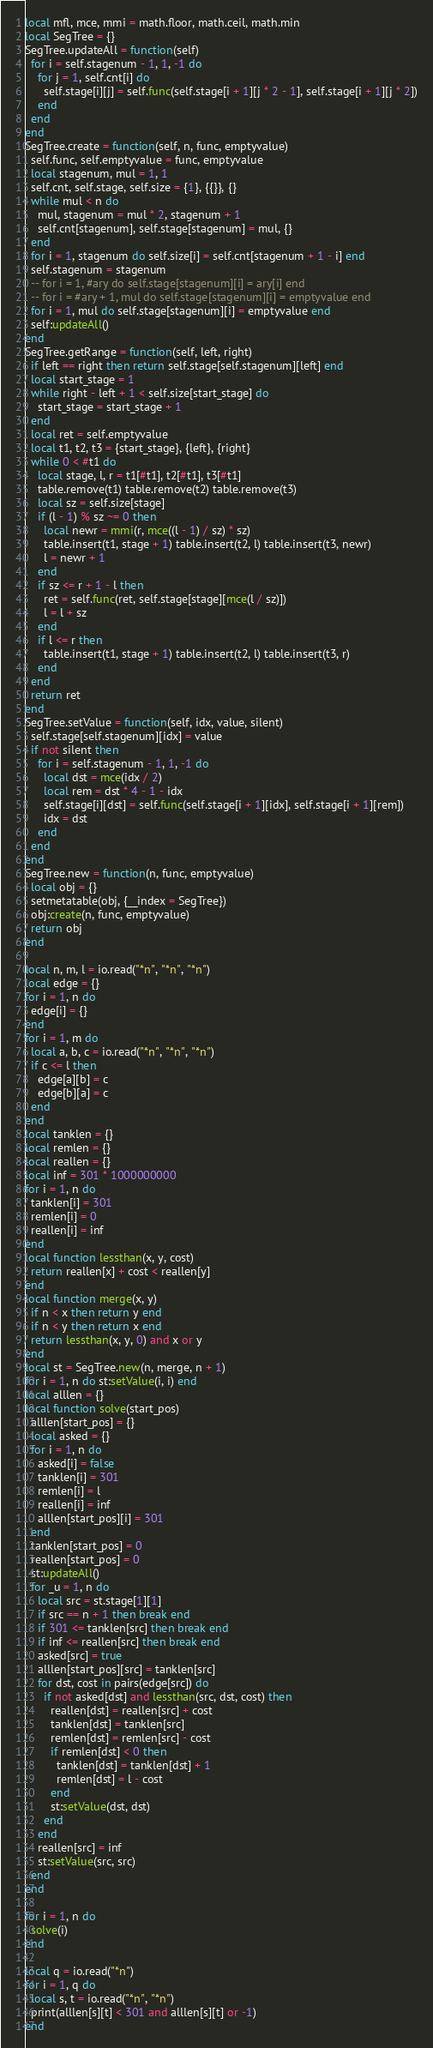<code> <loc_0><loc_0><loc_500><loc_500><_Lua_>local mfl, mce, mmi = math.floor, math.ceil, math.min
local SegTree = {}
SegTree.updateAll = function(self)
  for i = self.stagenum - 1, 1, -1 do
    for j = 1, self.cnt[i] do
      self.stage[i][j] = self.func(self.stage[i + 1][j * 2 - 1], self.stage[i + 1][j * 2])
    end
  end
end
SegTree.create = function(self, n, func, emptyvalue)
  self.func, self.emptyvalue = func, emptyvalue
  local stagenum, mul = 1, 1
  self.cnt, self.stage, self.size = {1}, {{}}, {}
  while mul < n do
    mul, stagenum = mul * 2, stagenum + 1
    self.cnt[stagenum], self.stage[stagenum] = mul, {}
  end
  for i = 1, stagenum do self.size[i] = self.cnt[stagenum + 1 - i] end
  self.stagenum = stagenum
  -- for i = 1, #ary do self.stage[stagenum][i] = ary[i] end
  -- for i = #ary + 1, mul do self.stage[stagenum][i] = emptyvalue end
  for i = 1, mul do self.stage[stagenum][i] = emptyvalue end
  self:updateAll()
end
SegTree.getRange = function(self, left, right)
  if left == right then return self.stage[self.stagenum][left] end
  local start_stage = 1
  while right - left + 1 < self.size[start_stage] do
    start_stage = start_stage + 1
  end
  local ret = self.emptyvalue
  local t1, t2, t3 = {start_stage}, {left}, {right}
  while 0 < #t1 do
    local stage, l, r = t1[#t1], t2[#t1], t3[#t1]
    table.remove(t1) table.remove(t2) table.remove(t3)
    local sz = self.size[stage]
    if (l - 1) % sz ~= 0 then
      local newr = mmi(r, mce((l - 1) / sz) * sz)
      table.insert(t1, stage + 1) table.insert(t2, l) table.insert(t3, newr)
      l = newr + 1
    end
    if sz <= r + 1 - l then
      ret = self.func(ret, self.stage[stage][mce(l / sz)])
      l = l + sz
    end
    if l <= r then
      table.insert(t1, stage + 1) table.insert(t2, l) table.insert(t3, r)
    end
  end
  return ret
end
SegTree.setValue = function(self, idx, value, silent)
  self.stage[self.stagenum][idx] = value
  if not silent then
    for i = self.stagenum - 1, 1, -1 do
      local dst = mce(idx / 2)
      local rem = dst * 4 - 1 - idx
      self.stage[i][dst] = self.func(self.stage[i + 1][idx], self.stage[i + 1][rem])
      idx = dst
    end
  end
end
SegTree.new = function(n, func, emptyvalue)
  local obj = {}
  setmetatable(obj, {__index = SegTree})
  obj:create(n, func, emptyvalue)
  return obj
end

local n, m, l = io.read("*n", "*n", "*n")
local edge = {}
for i = 1, n do
  edge[i] = {}
end
for i = 1, m do
  local a, b, c = io.read("*n", "*n", "*n")
  if c <= l then
    edge[a][b] = c
    edge[b][a] = c
  end
end
local tanklen = {}
local remlen = {}
local reallen = {}
local inf = 301 * 1000000000
for i = 1, n do
  tanklen[i] = 301
  remlen[i] = 0
  reallen[i] = inf
end
local function lessthan(x, y, cost)
  return reallen[x] + cost < reallen[y]
end
local function merge(x, y)
  if n < x then return y end
  if n < y then return x end
  return lessthan(x, y, 0) and x or y
end
local st = SegTree.new(n, merge, n + 1)
for i = 1, n do st:setValue(i, i) end
local alllen = {}
local function solve(start_pos)
  alllen[start_pos] = {}
  local asked = {}
  for i = 1, n do
    asked[i] = false
    tanklen[i] = 301
    remlen[i] = l
    reallen[i] = inf
    alllen[start_pos][i] = 301
  end
  tanklen[start_pos] = 0
  reallen[start_pos] = 0
  st:updateAll()
  for _u = 1, n do
    local src = st.stage[1][1]
    if src == n + 1 then break end
    if 301 <= tanklen[src] then break end
    if inf <= reallen[src] then break end
    asked[src] = true
    alllen[start_pos][src] = tanklen[src]
    for dst, cost in pairs(edge[src]) do
      if not asked[dst] and lessthan(src, dst, cost) then
        reallen[dst] = reallen[src] + cost
        tanklen[dst] = tanklen[src]
        remlen[dst] = remlen[src] - cost
        if remlen[dst] < 0 then
          tanklen[dst] = tanklen[dst] + 1
          remlen[dst] = l - cost
        end
        st:setValue(dst, dst)
      end
    end
    reallen[src] = inf
    st:setValue(src, src)
  end
end

for i = 1, n do
  solve(i)
end

local q = io.read("*n")
for i = 1, q do
  local s, t = io.read("*n", "*n")
  print(alllen[s][t] < 301 and alllen[s][t] or -1)
end
</code> 